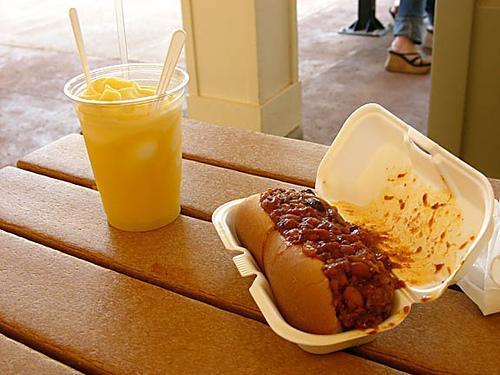How many people are in the photo?
Give a very brief answer. 1. How many beds are in the room?
Give a very brief answer. 0. 